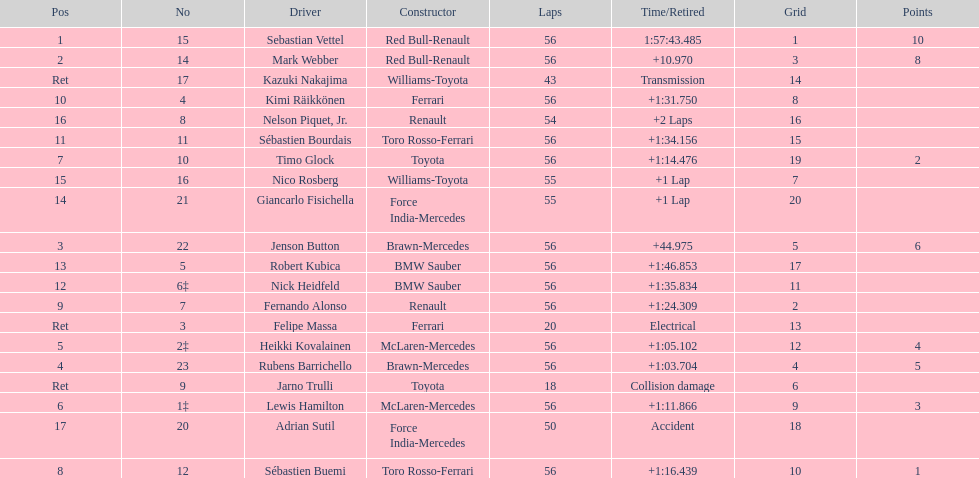Would you be able to parse every entry in this table? {'header': ['Pos', 'No', 'Driver', 'Constructor', 'Laps', 'Time/Retired', 'Grid', 'Points'], 'rows': [['1', '15', 'Sebastian Vettel', 'Red Bull-Renault', '56', '1:57:43.485', '1', '10'], ['2', '14', 'Mark Webber', 'Red Bull-Renault', '56', '+10.970', '3', '8'], ['Ret', '17', 'Kazuki Nakajima', 'Williams-Toyota', '43', 'Transmission', '14', ''], ['10', '4', 'Kimi Räikkönen', 'Ferrari', '56', '+1:31.750', '8', ''], ['16', '8', 'Nelson Piquet, Jr.', 'Renault', '54', '+2 Laps', '16', ''], ['11', '11', 'Sébastien Bourdais', 'Toro Rosso-Ferrari', '56', '+1:34.156', '15', ''], ['7', '10', 'Timo Glock', 'Toyota', '56', '+1:14.476', '19', '2'], ['15', '16', 'Nico Rosberg', 'Williams-Toyota', '55', '+1 Lap', '7', ''], ['14', '21', 'Giancarlo Fisichella', 'Force India-Mercedes', '55', '+1 Lap', '20', ''], ['3', '22', 'Jenson Button', 'Brawn-Mercedes', '56', '+44.975', '5', '6'], ['13', '5', 'Robert Kubica', 'BMW Sauber', '56', '+1:46.853', '17', ''], ['12', '6‡', 'Nick Heidfeld', 'BMW Sauber', '56', '+1:35.834', '11', ''], ['9', '7', 'Fernando Alonso', 'Renault', '56', '+1:24.309', '2', ''], ['Ret', '3', 'Felipe Massa', 'Ferrari', '20', 'Electrical', '13', ''], ['5', '2‡', 'Heikki Kovalainen', 'McLaren-Mercedes', '56', '+1:05.102', '12', '4'], ['4', '23', 'Rubens Barrichello', 'Brawn-Mercedes', '56', '+1:03.704', '4', '5'], ['Ret', '9', 'Jarno Trulli', 'Toyota', '18', 'Collision damage', '6', ''], ['6', '1‡', 'Lewis Hamilton', 'McLaren-Mercedes', '56', '+1:11.866', '9', '3'], ['17', '20', 'Adrian Sutil', 'Force India-Mercedes', '50', 'Accident', '18', ''], ['8', '12', 'Sébastien Buemi', 'Toro Rosso-Ferrari', '56', '+1:16.439', '10', '1']]} How many laps in total is the race? 56. 